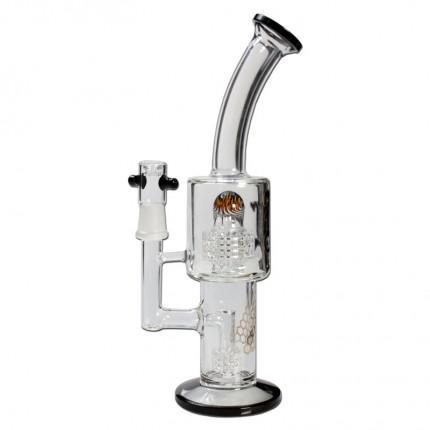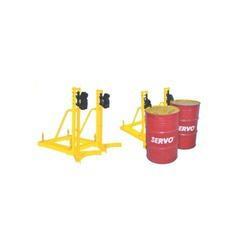The first image is the image on the left, the second image is the image on the right. Considering the images on both sides, is "There are more containers in the image on the right." valid? Answer yes or no. Yes. 